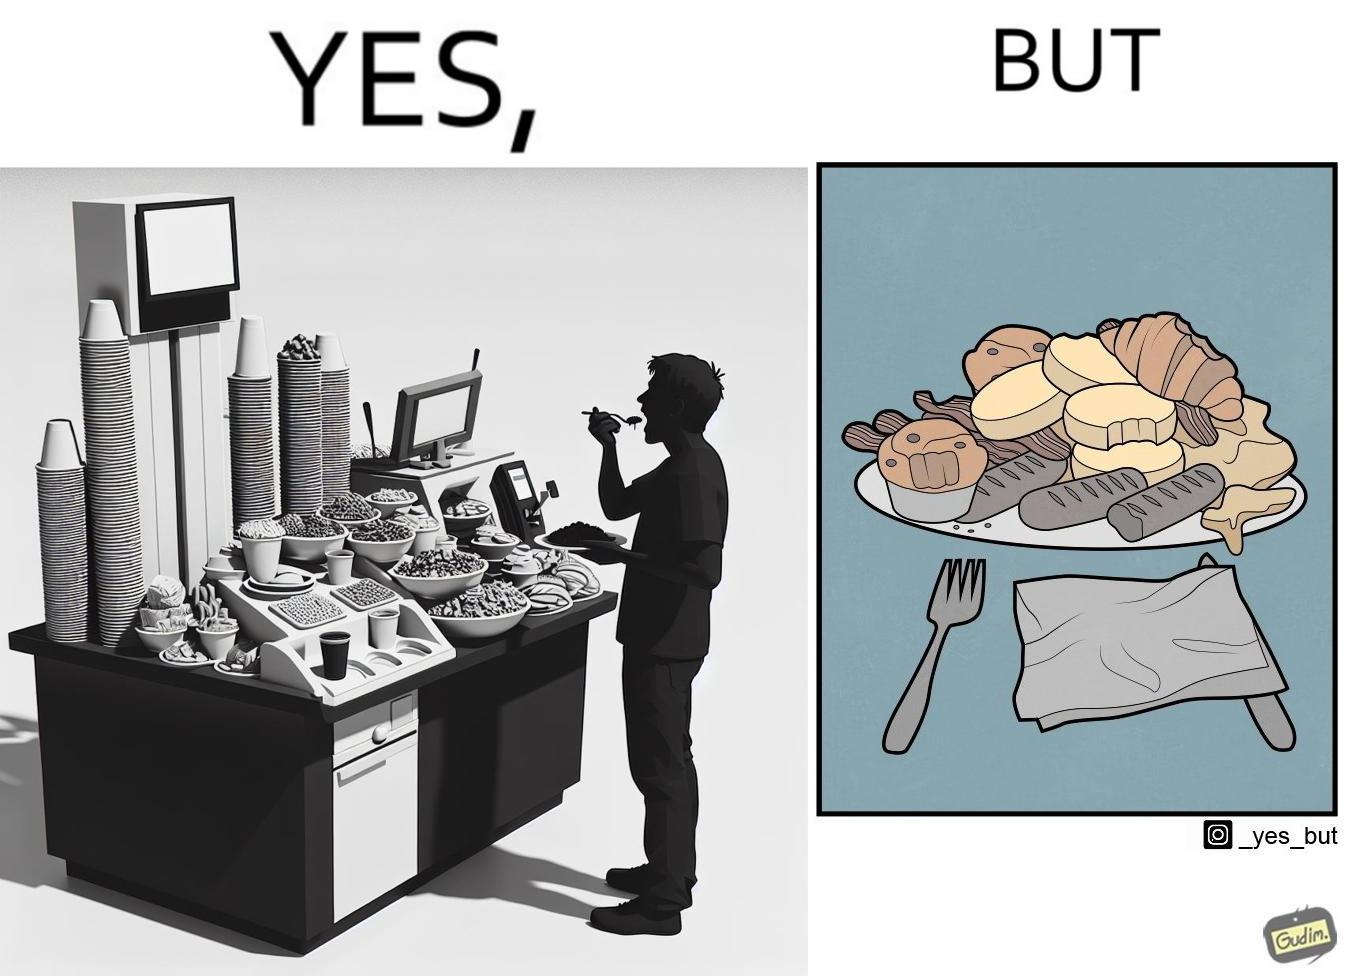What is shown in the left half versus the right half of this image? In the left part of the image: The image shows a man overfilling his plate with different kinds of food from a self serving station with various items placed on it. In the right part of the image: The image shows a plate full of food items. Most of the items seems untouched and few have been taken a bite from. 